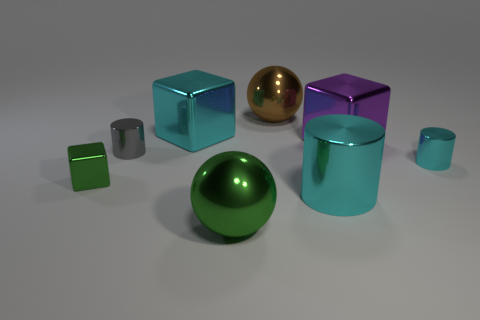What number of objects are either large cyan objects that are in front of the tiny gray thing or metallic cylinders on the left side of the brown metal ball?
Provide a succinct answer. 2. Do the gray shiny cylinder and the green metallic cube have the same size?
Make the answer very short. Yes. Is the number of cyan metallic objects greater than the number of things?
Provide a succinct answer. No. How many other things are there of the same color as the big shiny cylinder?
Provide a succinct answer. 2. How many things are small green cubes or large shiny cubes?
Offer a very short reply. 3. There is a tiny metal object right of the brown metallic ball; is it the same shape as the brown shiny object?
Provide a succinct answer. No. The tiny cylinder that is to the left of the shiny cylinder in front of the tiny green object is what color?
Provide a succinct answer. Gray. Is the number of tiny green things less than the number of big blue matte cubes?
Provide a succinct answer. No. Is there a large sphere that has the same material as the cyan cube?
Your answer should be very brief. Yes. There is a brown thing; does it have the same shape as the green metal thing that is on the right side of the small green cube?
Keep it short and to the point. Yes. 